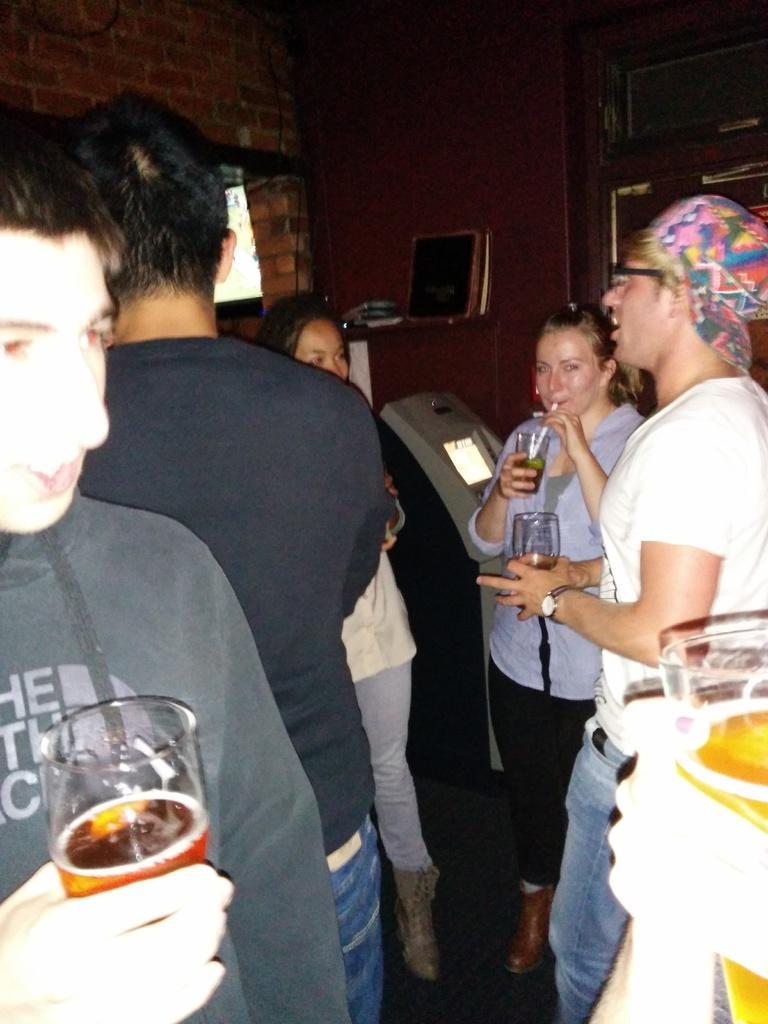Describe this image in one or two sentences. In this picture we can see some persons are standing and holding a glass with their hands. And there is a wall on the background. 